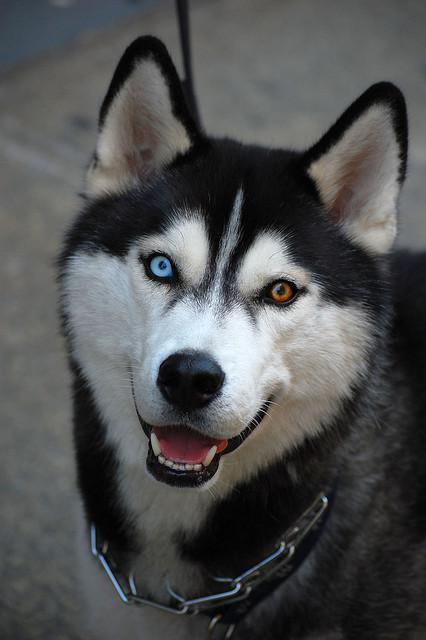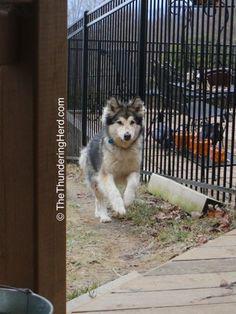The first image is the image on the left, the second image is the image on the right. Analyze the images presented: Is the assertion "One image has one dog and the other image has a pack of dogs." valid? Answer yes or no. No. The first image is the image on the left, the second image is the image on the right. Examine the images to the left and right. Is the description "A sled is being pulled over the snow by a team of dogs in one of the images." accurate? Answer yes or no. No. 